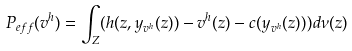Convert formula to latex. <formula><loc_0><loc_0><loc_500><loc_500>P _ { e f f } ( v ^ { h } ) = \int _ { Z } ( h ( z , y _ { v ^ { h } } ( z ) ) - v ^ { h } ( z ) - c ( y _ { v ^ { h } } ( z ) ) ) d \nu ( z )</formula> 